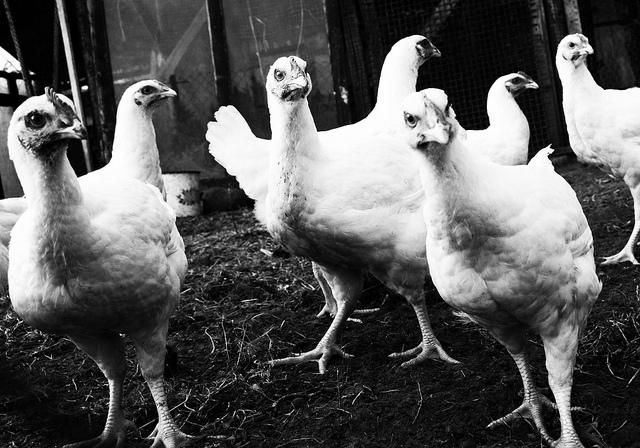What kind of bird is that?
Give a very brief answer. Chicken. Is the picture colored?
Be succinct. No. What kind of animals are shown?
Give a very brief answer. Chickens. 